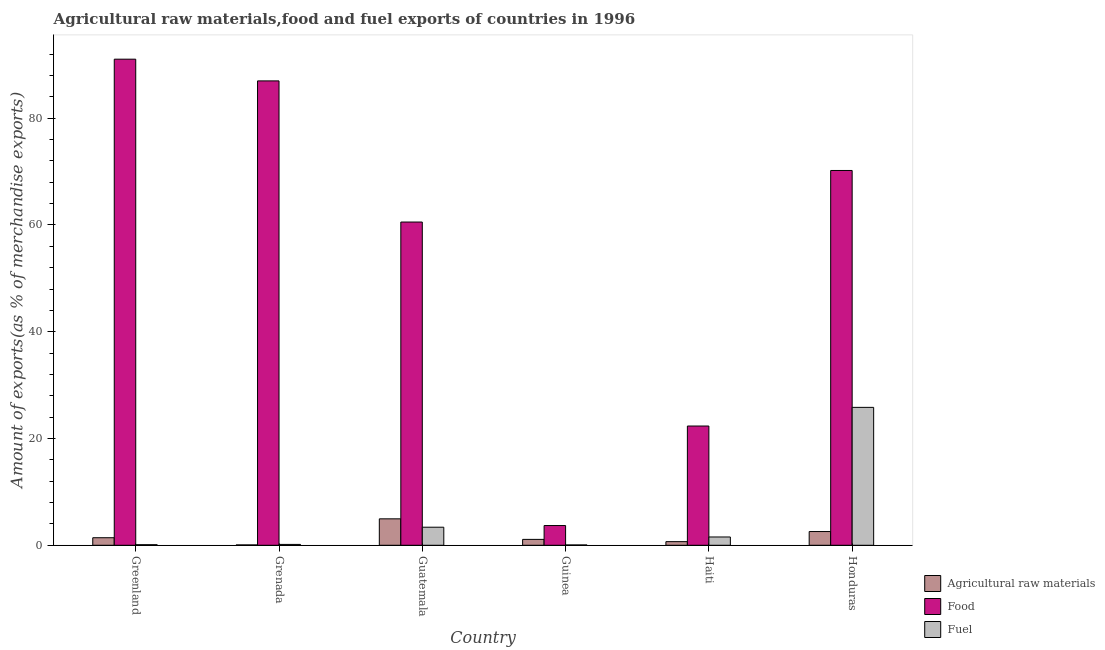How many different coloured bars are there?
Your response must be concise. 3. Are the number of bars on each tick of the X-axis equal?
Your answer should be very brief. Yes. How many bars are there on the 5th tick from the left?
Your answer should be compact. 3. How many bars are there on the 2nd tick from the right?
Provide a short and direct response. 3. What is the label of the 2nd group of bars from the left?
Offer a terse response. Grenada. In how many cases, is the number of bars for a given country not equal to the number of legend labels?
Your response must be concise. 0. What is the percentage of food exports in Honduras?
Provide a short and direct response. 70.21. Across all countries, what is the maximum percentage of raw materials exports?
Ensure brevity in your answer.  4.95. Across all countries, what is the minimum percentage of fuel exports?
Your answer should be compact. 0.06. In which country was the percentage of fuel exports maximum?
Your response must be concise. Honduras. In which country was the percentage of fuel exports minimum?
Offer a terse response. Guinea. What is the total percentage of fuel exports in the graph?
Make the answer very short. 31.1. What is the difference between the percentage of fuel exports in Grenada and that in Guinea?
Keep it short and to the point. 0.1. What is the difference between the percentage of food exports in Grenada and the percentage of fuel exports in Guatemala?
Ensure brevity in your answer.  83.61. What is the average percentage of fuel exports per country?
Keep it short and to the point. 5.18. What is the difference between the percentage of raw materials exports and percentage of fuel exports in Haiti?
Your answer should be very brief. -0.87. In how many countries, is the percentage of raw materials exports greater than 16 %?
Keep it short and to the point. 0. What is the ratio of the percentage of food exports in Guatemala to that in Guinea?
Your answer should be very brief. 16.38. Is the percentage of fuel exports in Guinea less than that in Haiti?
Keep it short and to the point. Yes. Is the difference between the percentage of fuel exports in Grenada and Guinea greater than the difference between the percentage of food exports in Grenada and Guinea?
Offer a very short reply. No. What is the difference between the highest and the second highest percentage of raw materials exports?
Provide a succinct answer. 2.38. What is the difference between the highest and the lowest percentage of food exports?
Your response must be concise. 87.36. What does the 1st bar from the left in Haiti represents?
Give a very brief answer. Agricultural raw materials. What does the 1st bar from the right in Haiti represents?
Your answer should be compact. Fuel. How many bars are there?
Provide a short and direct response. 18. Does the graph contain any zero values?
Provide a succinct answer. No. Does the graph contain grids?
Provide a short and direct response. No. Where does the legend appear in the graph?
Offer a terse response. Bottom right. What is the title of the graph?
Provide a short and direct response. Agricultural raw materials,food and fuel exports of countries in 1996. Does "Taxes" appear as one of the legend labels in the graph?
Your answer should be compact. No. What is the label or title of the X-axis?
Your response must be concise. Country. What is the label or title of the Y-axis?
Your answer should be very brief. Amount of exports(as % of merchandise exports). What is the Amount of exports(as % of merchandise exports) in Agricultural raw materials in Greenland?
Provide a short and direct response. 1.41. What is the Amount of exports(as % of merchandise exports) in Food in Greenland?
Provide a succinct answer. 91.06. What is the Amount of exports(as % of merchandise exports) in Fuel in Greenland?
Your answer should be very brief. 0.11. What is the Amount of exports(as % of merchandise exports) of Agricultural raw materials in Grenada?
Provide a short and direct response. 0.07. What is the Amount of exports(as % of merchandise exports) of Food in Grenada?
Provide a succinct answer. 86.99. What is the Amount of exports(as % of merchandise exports) in Fuel in Grenada?
Make the answer very short. 0.16. What is the Amount of exports(as % of merchandise exports) of Agricultural raw materials in Guatemala?
Provide a short and direct response. 4.95. What is the Amount of exports(as % of merchandise exports) in Food in Guatemala?
Provide a succinct answer. 60.55. What is the Amount of exports(as % of merchandise exports) of Fuel in Guatemala?
Keep it short and to the point. 3.38. What is the Amount of exports(as % of merchandise exports) in Agricultural raw materials in Guinea?
Provide a short and direct response. 1.1. What is the Amount of exports(as % of merchandise exports) in Food in Guinea?
Provide a succinct answer. 3.7. What is the Amount of exports(as % of merchandise exports) of Fuel in Guinea?
Your answer should be very brief. 0.06. What is the Amount of exports(as % of merchandise exports) of Agricultural raw materials in Haiti?
Make the answer very short. 0.68. What is the Amount of exports(as % of merchandise exports) in Food in Haiti?
Offer a terse response. 22.34. What is the Amount of exports(as % of merchandise exports) of Fuel in Haiti?
Provide a succinct answer. 1.55. What is the Amount of exports(as % of merchandise exports) of Agricultural raw materials in Honduras?
Keep it short and to the point. 2.57. What is the Amount of exports(as % of merchandise exports) of Food in Honduras?
Provide a succinct answer. 70.21. What is the Amount of exports(as % of merchandise exports) in Fuel in Honduras?
Provide a short and direct response. 25.83. Across all countries, what is the maximum Amount of exports(as % of merchandise exports) in Agricultural raw materials?
Offer a terse response. 4.95. Across all countries, what is the maximum Amount of exports(as % of merchandise exports) of Food?
Keep it short and to the point. 91.06. Across all countries, what is the maximum Amount of exports(as % of merchandise exports) in Fuel?
Your answer should be compact. 25.83. Across all countries, what is the minimum Amount of exports(as % of merchandise exports) of Agricultural raw materials?
Your answer should be compact. 0.07. Across all countries, what is the minimum Amount of exports(as % of merchandise exports) of Food?
Offer a terse response. 3.7. Across all countries, what is the minimum Amount of exports(as % of merchandise exports) of Fuel?
Make the answer very short. 0.06. What is the total Amount of exports(as % of merchandise exports) of Agricultural raw materials in the graph?
Make the answer very short. 10.79. What is the total Amount of exports(as % of merchandise exports) of Food in the graph?
Make the answer very short. 334.84. What is the total Amount of exports(as % of merchandise exports) in Fuel in the graph?
Offer a very short reply. 31.1. What is the difference between the Amount of exports(as % of merchandise exports) in Agricultural raw materials in Greenland and that in Grenada?
Offer a very short reply. 1.35. What is the difference between the Amount of exports(as % of merchandise exports) of Food in Greenland and that in Grenada?
Your response must be concise. 4.07. What is the difference between the Amount of exports(as % of merchandise exports) of Fuel in Greenland and that in Grenada?
Give a very brief answer. -0.05. What is the difference between the Amount of exports(as % of merchandise exports) in Agricultural raw materials in Greenland and that in Guatemala?
Your answer should be compact. -3.54. What is the difference between the Amount of exports(as % of merchandise exports) of Food in Greenland and that in Guatemala?
Provide a succinct answer. 30.51. What is the difference between the Amount of exports(as % of merchandise exports) of Fuel in Greenland and that in Guatemala?
Ensure brevity in your answer.  -3.27. What is the difference between the Amount of exports(as % of merchandise exports) of Agricultural raw materials in Greenland and that in Guinea?
Ensure brevity in your answer.  0.31. What is the difference between the Amount of exports(as % of merchandise exports) of Food in Greenland and that in Guinea?
Give a very brief answer. 87.36. What is the difference between the Amount of exports(as % of merchandise exports) in Fuel in Greenland and that in Guinea?
Provide a succinct answer. 0.05. What is the difference between the Amount of exports(as % of merchandise exports) in Agricultural raw materials in Greenland and that in Haiti?
Your answer should be very brief. 0.74. What is the difference between the Amount of exports(as % of merchandise exports) in Food in Greenland and that in Haiti?
Keep it short and to the point. 68.72. What is the difference between the Amount of exports(as % of merchandise exports) in Fuel in Greenland and that in Haiti?
Keep it short and to the point. -1.44. What is the difference between the Amount of exports(as % of merchandise exports) of Agricultural raw materials in Greenland and that in Honduras?
Offer a terse response. -1.16. What is the difference between the Amount of exports(as % of merchandise exports) of Food in Greenland and that in Honduras?
Your answer should be very brief. 20.85. What is the difference between the Amount of exports(as % of merchandise exports) in Fuel in Greenland and that in Honduras?
Offer a very short reply. -25.72. What is the difference between the Amount of exports(as % of merchandise exports) of Agricultural raw materials in Grenada and that in Guatemala?
Your answer should be compact. -4.89. What is the difference between the Amount of exports(as % of merchandise exports) in Food in Grenada and that in Guatemala?
Your answer should be compact. 26.44. What is the difference between the Amount of exports(as % of merchandise exports) in Fuel in Grenada and that in Guatemala?
Offer a terse response. -3.22. What is the difference between the Amount of exports(as % of merchandise exports) of Agricultural raw materials in Grenada and that in Guinea?
Ensure brevity in your answer.  -1.04. What is the difference between the Amount of exports(as % of merchandise exports) of Food in Grenada and that in Guinea?
Give a very brief answer. 83.29. What is the difference between the Amount of exports(as % of merchandise exports) in Fuel in Grenada and that in Guinea?
Give a very brief answer. 0.1. What is the difference between the Amount of exports(as % of merchandise exports) of Agricultural raw materials in Grenada and that in Haiti?
Provide a succinct answer. -0.61. What is the difference between the Amount of exports(as % of merchandise exports) of Food in Grenada and that in Haiti?
Your answer should be compact. 64.65. What is the difference between the Amount of exports(as % of merchandise exports) in Fuel in Grenada and that in Haiti?
Keep it short and to the point. -1.39. What is the difference between the Amount of exports(as % of merchandise exports) in Agricultural raw materials in Grenada and that in Honduras?
Your answer should be very brief. -2.51. What is the difference between the Amount of exports(as % of merchandise exports) of Food in Grenada and that in Honduras?
Your answer should be very brief. 16.78. What is the difference between the Amount of exports(as % of merchandise exports) of Fuel in Grenada and that in Honduras?
Your answer should be compact. -25.67. What is the difference between the Amount of exports(as % of merchandise exports) of Agricultural raw materials in Guatemala and that in Guinea?
Your answer should be compact. 3.85. What is the difference between the Amount of exports(as % of merchandise exports) of Food in Guatemala and that in Guinea?
Your response must be concise. 56.85. What is the difference between the Amount of exports(as % of merchandise exports) of Fuel in Guatemala and that in Guinea?
Your response must be concise. 3.32. What is the difference between the Amount of exports(as % of merchandise exports) in Agricultural raw materials in Guatemala and that in Haiti?
Ensure brevity in your answer.  4.27. What is the difference between the Amount of exports(as % of merchandise exports) in Food in Guatemala and that in Haiti?
Give a very brief answer. 38.21. What is the difference between the Amount of exports(as % of merchandise exports) of Fuel in Guatemala and that in Haiti?
Offer a terse response. 1.83. What is the difference between the Amount of exports(as % of merchandise exports) of Agricultural raw materials in Guatemala and that in Honduras?
Keep it short and to the point. 2.38. What is the difference between the Amount of exports(as % of merchandise exports) of Food in Guatemala and that in Honduras?
Offer a very short reply. -9.66. What is the difference between the Amount of exports(as % of merchandise exports) in Fuel in Guatemala and that in Honduras?
Keep it short and to the point. -22.45. What is the difference between the Amount of exports(as % of merchandise exports) of Agricultural raw materials in Guinea and that in Haiti?
Provide a succinct answer. 0.42. What is the difference between the Amount of exports(as % of merchandise exports) in Food in Guinea and that in Haiti?
Provide a short and direct response. -18.64. What is the difference between the Amount of exports(as % of merchandise exports) of Fuel in Guinea and that in Haiti?
Offer a very short reply. -1.49. What is the difference between the Amount of exports(as % of merchandise exports) in Agricultural raw materials in Guinea and that in Honduras?
Your answer should be very brief. -1.47. What is the difference between the Amount of exports(as % of merchandise exports) in Food in Guinea and that in Honduras?
Provide a succinct answer. -66.51. What is the difference between the Amount of exports(as % of merchandise exports) of Fuel in Guinea and that in Honduras?
Offer a terse response. -25.77. What is the difference between the Amount of exports(as % of merchandise exports) of Agricultural raw materials in Haiti and that in Honduras?
Provide a succinct answer. -1.89. What is the difference between the Amount of exports(as % of merchandise exports) in Food in Haiti and that in Honduras?
Give a very brief answer. -47.87. What is the difference between the Amount of exports(as % of merchandise exports) of Fuel in Haiti and that in Honduras?
Provide a short and direct response. -24.28. What is the difference between the Amount of exports(as % of merchandise exports) in Agricultural raw materials in Greenland and the Amount of exports(as % of merchandise exports) in Food in Grenada?
Ensure brevity in your answer.  -85.58. What is the difference between the Amount of exports(as % of merchandise exports) of Agricultural raw materials in Greenland and the Amount of exports(as % of merchandise exports) of Fuel in Grenada?
Offer a terse response. 1.25. What is the difference between the Amount of exports(as % of merchandise exports) in Food in Greenland and the Amount of exports(as % of merchandise exports) in Fuel in Grenada?
Your response must be concise. 90.9. What is the difference between the Amount of exports(as % of merchandise exports) of Agricultural raw materials in Greenland and the Amount of exports(as % of merchandise exports) of Food in Guatemala?
Offer a very short reply. -59.14. What is the difference between the Amount of exports(as % of merchandise exports) of Agricultural raw materials in Greenland and the Amount of exports(as % of merchandise exports) of Fuel in Guatemala?
Your answer should be compact. -1.97. What is the difference between the Amount of exports(as % of merchandise exports) of Food in Greenland and the Amount of exports(as % of merchandise exports) of Fuel in Guatemala?
Ensure brevity in your answer.  87.67. What is the difference between the Amount of exports(as % of merchandise exports) in Agricultural raw materials in Greenland and the Amount of exports(as % of merchandise exports) in Food in Guinea?
Ensure brevity in your answer.  -2.28. What is the difference between the Amount of exports(as % of merchandise exports) of Agricultural raw materials in Greenland and the Amount of exports(as % of merchandise exports) of Fuel in Guinea?
Provide a succinct answer. 1.35. What is the difference between the Amount of exports(as % of merchandise exports) in Food in Greenland and the Amount of exports(as % of merchandise exports) in Fuel in Guinea?
Offer a very short reply. 91. What is the difference between the Amount of exports(as % of merchandise exports) of Agricultural raw materials in Greenland and the Amount of exports(as % of merchandise exports) of Food in Haiti?
Offer a very short reply. -20.92. What is the difference between the Amount of exports(as % of merchandise exports) of Agricultural raw materials in Greenland and the Amount of exports(as % of merchandise exports) of Fuel in Haiti?
Make the answer very short. -0.14. What is the difference between the Amount of exports(as % of merchandise exports) of Food in Greenland and the Amount of exports(as % of merchandise exports) of Fuel in Haiti?
Give a very brief answer. 89.5. What is the difference between the Amount of exports(as % of merchandise exports) of Agricultural raw materials in Greenland and the Amount of exports(as % of merchandise exports) of Food in Honduras?
Offer a terse response. -68.79. What is the difference between the Amount of exports(as % of merchandise exports) of Agricultural raw materials in Greenland and the Amount of exports(as % of merchandise exports) of Fuel in Honduras?
Offer a terse response. -24.42. What is the difference between the Amount of exports(as % of merchandise exports) in Food in Greenland and the Amount of exports(as % of merchandise exports) in Fuel in Honduras?
Keep it short and to the point. 65.22. What is the difference between the Amount of exports(as % of merchandise exports) in Agricultural raw materials in Grenada and the Amount of exports(as % of merchandise exports) in Food in Guatemala?
Your answer should be compact. -60.48. What is the difference between the Amount of exports(as % of merchandise exports) of Agricultural raw materials in Grenada and the Amount of exports(as % of merchandise exports) of Fuel in Guatemala?
Keep it short and to the point. -3.32. What is the difference between the Amount of exports(as % of merchandise exports) in Food in Grenada and the Amount of exports(as % of merchandise exports) in Fuel in Guatemala?
Offer a terse response. 83.61. What is the difference between the Amount of exports(as % of merchandise exports) in Agricultural raw materials in Grenada and the Amount of exports(as % of merchandise exports) in Food in Guinea?
Make the answer very short. -3.63. What is the difference between the Amount of exports(as % of merchandise exports) in Agricultural raw materials in Grenada and the Amount of exports(as % of merchandise exports) in Fuel in Guinea?
Provide a succinct answer. 0.01. What is the difference between the Amount of exports(as % of merchandise exports) of Food in Grenada and the Amount of exports(as % of merchandise exports) of Fuel in Guinea?
Your answer should be very brief. 86.93. What is the difference between the Amount of exports(as % of merchandise exports) in Agricultural raw materials in Grenada and the Amount of exports(as % of merchandise exports) in Food in Haiti?
Offer a terse response. -22.27. What is the difference between the Amount of exports(as % of merchandise exports) in Agricultural raw materials in Grenada and the Amount of exports(as % of merchandise exports) in Fuel in Haiti?
Your answer should be very brief. -1.49. What is the difference between the Amount of exports(as % of merchandise exports) in Food in Grenada and the Amount of exports(as % of merchandise exports) in Fuel in Haiti?
Your response must be concise. 85.44. What is the difference between the Amount of exports(as % of merchandise exports) in Agricultural raw materials in Grenada and the Amount of exports(as % of merchandise exports) in Food in Honduras?
Make the answer very short. -70.14. What is the difference between the Amount of exports(as % of merchandise exports) in Agricultural raw materials in Grenada and the Amount of exports(as % of merchandise exports) in Fuel in Honduras?
Provide a short and direct response. -25.77. What is the difference between the Amount of exports(as % of merchandise exports) of Food in Grenada and the Amount of exports(as % of merchandise exports) of Fuel in Honduras?
Your answer should be very brief. 61.16. What is the difference between the Amount of exports(as % of merchandise exports) of Agricultural raw materials in Guatemala and the Amount of exports(as % of merchandise exports) of Food in Guinea?
Your answer should be compact. 1.26. What is the difference between the Amount of exports(as % of merchandise exports) in Agricultural raw materials in Guatemala and the Amount of exports(as % of merchandise exports) in Fuel in Guinea?
Give a very brief answer. 4.89. What is the difference between the Amount of exports(as % of merchandise exports) in Food in Guatemala and the Amount of exports(as % of merchandise exports) in Fuel in Guinea?
Provide a succinct answer. 60.49. What is the difference between the Amount of exports(as % of merchandise exports) in Agricultural raw materials in Guatemala and the Amount of exports(as % of merchandise exports) in Food in Haiti?
Provide a succinct answer. -17.39. What is the difference between the Amount of exports(as % of merchandise exports) in Agricultural raw materials in Guatemala and the Amount of exports(as % of merchandise exports) in Fuel in Haiti?
Your answer should be compact. 3.4. What is the difference between the Amount of exports(as % of merchandise exports) of Food in Guatemala and the Amount of exports(as % of merchandise exports) of Fuel in Haiti?
Offer a terse response. 59. What is the difference between the Amount of exports(as % of merchandise exports) of Agricultural raw materials in Guatemala and the Amount of exports(as % of merchandise exports) of Food in Honduras?
Make the answer very short. -65.26. What is the difference between the Amount of exports(as % of merchandise exports) of Agricultural raw materials in Guatemala and the Amount of exports(as % of merchandise exports) of Fuel in Honduras?
Keep it short and to the point. -20.88. What is the difference between the Amount of exports(as % of merchandise exports) in Food in Guatemala and the Amount of exports(as % of merchandise exports) in Fuel in Honduras?
Give a very brief answer. 34.72. What is the difference between the Amount of exports(as % of merchandise exports) of Agricultural raw materials in Guinea and the Amount of exports(as % of merchandise exports) of Food in Haiti?
Make the answer very short. -21.23. What is the difference between the Amount of exports(as % of merchandise exports) in Agricultural raw materials in Guinea and the Amount of exports(as % of merchandise exports) in Fuel in Haiti?
Provide a short and direct response. -0.45. What is the difference between the Amount of exports(as % of merchandise exports) in Food in Guinea and the Amount of exports(as % of merchandise exports) in Fuel in Haiti?
Give a very brief answer. 2.14. What is the difference between the Amount of exports(as % of merchandise exports) in Agricultural raw materials in Guinea and the Amount of exports(as % of merchandise exports) in Food in Honduras?
Offer a terse response. -69.11. What is the difference between the Amount of exports(as % of merchandise exports) in Agricultural raw materials in Guinea and the Amount of exports(as % of merchandise exports) in Fuel in Honduras?
Your answer should be very brief. -24.73. What is the difference between the Amount of exports(as % of merchandise exports) in Food in Guinea and the Amount of exports(as % of merchandise exports) in Fuel in Honduras?
Make the answer very short. -22.14. What is the difference between the Amount of exports(as % of merchandise exports) of Agricultural raw materials in Haiti and the Amount of exports(as % of merchandise exports) of Food in Honduras?
Provide a short and direct response. -69.53. What is the difference between the Amount of exports(as % of merchandise exports) of Agricultural raw materials in Haiti and the Amount of exports(as % of merchandise exports) of Fuel in Honduras?
Provide a succinct answer. -25.15. What is the difference between the Amount of exports(as % of merchandise exports) of Food in Haiti and the Amount of exports(as % of merchandise exports) of Fuel in Honduras?
Ensure brevity in your answer.  -3.49. What is the average Amount of exports(as % of merchandise exports) of Agricultural raw materials per country?
Ensure brevity in your answer.  1.8. What is the average Amount of exports(as % of merchandise exports) of Food per country?
Provide a succinct answer. 55.81. What is the average Amount of exports(as % of merchandise exports) of Fuel per country?
Offer a very short reply. 5.18. What is the difference between the Amount of exports(as % of merchandise exports) of Agricultural raw materials and Amount of exports(as % of merchandise exports) of Food in Greenland?
Offer a very short reply. -89.64. What is the difference between the Amount of exports(as % of merchandise exports) of Agricultural raw materials and Amount of exports(as % of merchandise exports) of Fuel in Greenland?
Your answer should be compact. 1.3. What is the difference between the Amount of exports(as % of merchandise exports) of Food and Amount of exports(as % of merchandise exports) of Fuel in Greenland?
Keep it short and to the point. 90.95. What is the difference between the Amount of exports(as % of merchandise exports) in Agricultural raw materials and Amount of exports(as % of merchandise exports) in Food in Grenada?
Your answer should be very brief. -86.92. What is the difference between the Amount of exports(as % of merchandise exports) of Agricultural raw materials and Amount of exports(as % of merchandise exports) of Fuel in Grenada?
Your response must be concise. -0.09. What is the difference between the Amount of exports(as % of merchandise exports) in Food and Amount of exports(as % of merchandise exports) in Fuel in Grenada?
Provide a short and direct response. 86.83. What is the difference between the Amount of exports(as % of merchandise exports) in Agricultural raw materials and Amount of exports(as % of merchandise exports) in Food in Guatemala?
Give a very brief answer. -55.6. What is the difference between the Amount of exports(as % of merchandise exports) in Agricultural raw materials and Amount of exports(as % of merchandise exports) in Fuel in Guatemala?
Ensure brevity in your answer.  1.57. What is the difference between the Amount of exports(as % of merchandise exports) in Food and Amount of exports(as % of merchandise exports) in Fuel in Guatemala?
Your answer should be compact. 57.17. What is the difference between the Amount of exports(as % of merchandise exports) in Agricultural raw materials and Amount of exports(as % of merchandise exports) in Food in Guinea?
Your answer should be very brief. -2.59. What is the difference between the Amount of exports(as % of merchandise exports) of Agricultural raw materials and Amount of exports(as % of merchandise exports) of Fuel in Guinea?
Offer a terse response. 1.04. What is the difference between the Amount of exports(as % of merchandise exports) in Food and Amount of exports(as % of merchandise exports) in Fuel in Guinea?
Provide a short and direct response. 3.64. What is the difference between the Amount of exports(as % of merchandise exports) in Agricultural raw materials and Amount of exports(as % of merchandise exports) in Food in Haiti?
Keep it short and to the point. -21.66. What is the difference between the Amount of exports(as % of merchandise exports) of Agricultural raw materials and Amount of exports(as % of merchandise exports) of Fuel in Haiti?
Offer a terse response. -0.87. What is the difference between the Amount of exports(as % of merchandise exports) of Food and Amount of exports(as % of merchandise exports) of Fuel in Haiti?
Your answer should be compact. 20.78. What is the difference between the Amount of exports(as % of merchandise exports) of Agricultural raw materials and Amount of exports(as % of merchandise exports) of Food in Honduras?
Give a very brief answer. -67.64. What is the difference between the Amount of exports(as % of merchandise exports) of Agricultural raw materials and Amount of exports(as % of merchandise exports) of Fuel in Honduras?
Your response must be concise. -23.26. What is the difference between the Amount of exports(as % of merchandise exports) in Food and Amount of exports(as % of merchandise exports) in Fuel in Honduras?
Your response must be concise. 44.38. What is the ratio of the Amount of exports(as % of merchandise exports) in Agricultural raw materials in Greenland to that in Grenada?
Your answer should be very brief. 21.19. What is the ratio of the Amount of exports(as % of merchandise exports) in Food in Greenland to that in Grenada?
Keep it short and to the point. 1.05. What is the ratio of the Amount of exports(as % of merchandise exports) of Fuel in Greenland to that in Grenada?
Your answer should be very brief. 0.68. What is the ratio of the Amount of exports(as % of merchandise exports) in Agricultural raw materials in Greenland to that in Guatemala?
Give a very brief answer. 0.29. What is the ratio of the Amount of exports(as % of merchandise exports) in Food in Greenland to that in Guatemala?
Offer a terse response. 1.5. What is the ratio of the Amount of exports(as % of merchandise exports) of Fuel in Greenland to that in Guatemala?
Offer a terse response. 0.03. What is the ratio of the Amount of exports(as % of merchandise exports) in Agricultural raw materials in Greenland to that in Guinea?
Make the answer very short. 1.28. What is the ratio of the Amount of exports(as % of merchandise exports) in Food in Greenland to that in Guinea?
Provide a succinct answer. 24.63. What is the ratio of the Amount of exports(as % of merchandise exports) in Fuel in Greenland to that in Guinea?
Offer a terse response. 1.8. What is the ratio of the Amount of exports(as % of merchandise exports) of Agricultural raw materials in Greenland to that in Haiti?
Your answer should be compact. 2.08. What is the ratio of the Amount of exports(as % of merchandise exports) of Food in Greenland to that in Haiti?
Provide a short and direct response. 4.08. What is the ratio of the Amount of exports(as % of merchandise exports) of Fuel in Greenland to that in Haiti?
Offer a very short reply. 0.07. What is the ratio of the Amount of exports(as % of merchandise exports) of Agricultural raw materials in Greenland to that in Honduras?
Offer a very short reply. 0.55. What is the ratio of the Amount of exports(as % of merchandise exports) in Food in Greenland to that in Honduras?
Keep it short and to the point. 1.3. What is the ratio of the Amount of exports(as % of merchandise exports) of Fuel in Greenland to that in Honduras?
Offer a very short reply. 0. What is the ratio of the Amount of exports(as % of merchandise exports) of Agricultural raw materials in Grenada to that in Guatemala?
Your response must be concise. 0.01. What is the ratio of the Amount of exports(as % of merchandise exports) of Food in Grenada to that in Guatemala?
Provide a succinct answer. 1.44. What is the ratio of the Amount of exports(as % of merchandise exports) in Fuel in Grenada to that in Guatemala?
Provide a short and direct response. 0.05. What is the ratio of the Amount of exports(as % of merchandise exports) in Agricultural raw materials in Grenada to that in Guinea?
Your answer should be compact. 0.06. What is the ratio of the Amount of exports(as % of merchandise exports) of Food in Grenada to that in Guinea?
Your answer should be compact. 23.53. What is the ratio of the Amount of exports(as % of merchandise exports) in Fuel in Grenada to that in Guinea?
Make the answer very short. 2.65. What is the ratio of the Amount of exports(as % of merchandise exports) of Agricultural raw materials in Grenada to that in Haiti?
Keep it short and to the point. 0.1. What is the ratio of the Amount of exports(as % of merchandise exports) in Food in Grenada to that in Haiti?
Make the answer very short. 3.89. What is the ratio of the Amount of exports(as % of merchandise exports) of Fuel in Grenada to that in Haiti?
Your answer should be compact. 0.1. What is the ratio of the Amount of exports(as % of merchandise exports) in Agricultural raw materials in Grenada to that in Honduras?
Your answer should be very brief. 0.03. What is the ratio of the Amount of exports(as % of merchandise exports) of Food in Grenada to that in Honduras?
Offer a very short reply. 1.24. What is the ratio of the Amount of exports(as % of merchandise exports) of Fuel in Grenada to that in Honduras?
Offer a very short reply. 0.01. What is the ratio of the Amount of exports(as % of merchandise exports) of Agricultural raw materials in Guatemala to that in Guinea?
Make the answer very short. 4.49. What is the ratio of the Amount of exports(as % of merchandise exports) of Food in Guatemala to that in Guinea?
Provide a short and direct response. 16.38. What is the ratio of the Amount of exports(as % of merchandise exports) of Fuel in Guatemala to that in Guinea?
Ensure brevity in your answer.  55.56. What is the ratio of the Amount of exports(as % of merchandise exports) in Agricultural raw materials in Guatemala to that in Haiti?
Provide a succinct answer. 7.29. What is the ratio of the Amount of exports(as % of merchandise exports) of Food in Guatemala to that in Haiti?
Give a very brief answer. 2.71. What is the ratio of the Amount of exports(as % of merchandise exports) of Fuel in Guatemala to that in Haiti?
Offer a terse response. 2.18. What is the ratio of the Amount of exports(as % of merchandise exports) in Agricultural raw materials in Guatemala to that in Honduras?
Offer a terse response. 1.93. What is the ratio of the Amount of exports(as % of merchandise exports) in Food in Guatemala to that in Honduras?
Provide a succinct answer. 0.86. What is the ratio of the Amount of exports(as % of merchandise exports) of Fuel in Guatemala to that in Honduras?
Your response must be concise. 0.13. What is the ratio of the Amount of exports(as % of merchandise exports) in Agricultural raw materials in Guinea to that in Haiti?
Your response must be concise. 1.63. What is the ratio of the Amount of exports(as % of merchandise exports) of Food in Guinea to that in Haiti?
Your response must be concise. 0.17. What is the ratio of the Amount of exports(as % of merchandise exports) of Fuel in Guinea to that in Haiti?
Keep it short and to the point. 0.04. What is the ratio of the Amount of exports(as % of merchandise exports) of Agricultural raw materials in Guinea to that in Honduras?
Provide a succinct answer. 0.43. What is the ratio of the Amount of exports(as % of merchandise exports) of Food in Guinea to that in Honduras?
Give a very brief answer. 0.05. What is the ratio of the Amount of exports(as % of merchandise exports) of Fuel in Guinea to that in Honduras?
Keep it short and to the point. 0. What is the ratio of the Amount of exports(as % of merchandise exports) in Agricultural raw materials in Haiti to that in Honduras?
Offer a very short reply. 0.26. What is the ratio of the Amount of exports(as % of merchandise exports) of Food in Haiti to that in Honduras?
Give a very brief answer. 0.32. What is the ratio of the Amount of exports(as % of merchandise exports) of Fuel in Haiti to that in Honduras?
Offer a terse response. 0.06. What is the difference between the highest and the second highest Amount of exports(as % of merchandise exports) in Agricultural raw materials?
Your answer should be compact. 2.38. What is the difference between the highest and the second highest Amount of exports(as % of merchandise exports) of Food?
Keep it short and to the point. 4.07. What is the difference between the highest and the second highest Amount of exports(as % of merchandise exports) of Fuel?
Offer a very short reply. 22.45. What is the difference between the highest and the lowest Amount of exports(as % of merchandise exports) in Agricultural raw materials?
Offer a terse response. 4.89. What is the difference between the highest and the lowest Amount of exports(as % of merchandise exports) in Food?
Your answer should be very brief. 87.36. What is the difference between the highest and the lowest Amount of exports(as % of merchandise exports) of Fuel?
Your answer should be compact. 25.77. 